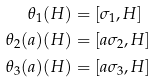Convert formula to latex. <formula><loc_0><loc_0><loc_500><loc_500>\theta _ { 1 } ( H ) & = [ \sigma _ { 1 } , H ] \\ \theta _ { 2 } ( a ) ( H ) & = [ a \sigma _ { 2 } , H ] \\ \theta _ { 3 } ( a ) ( H ) & = [ a \sigma _ { 3 } , H ]</formula> 